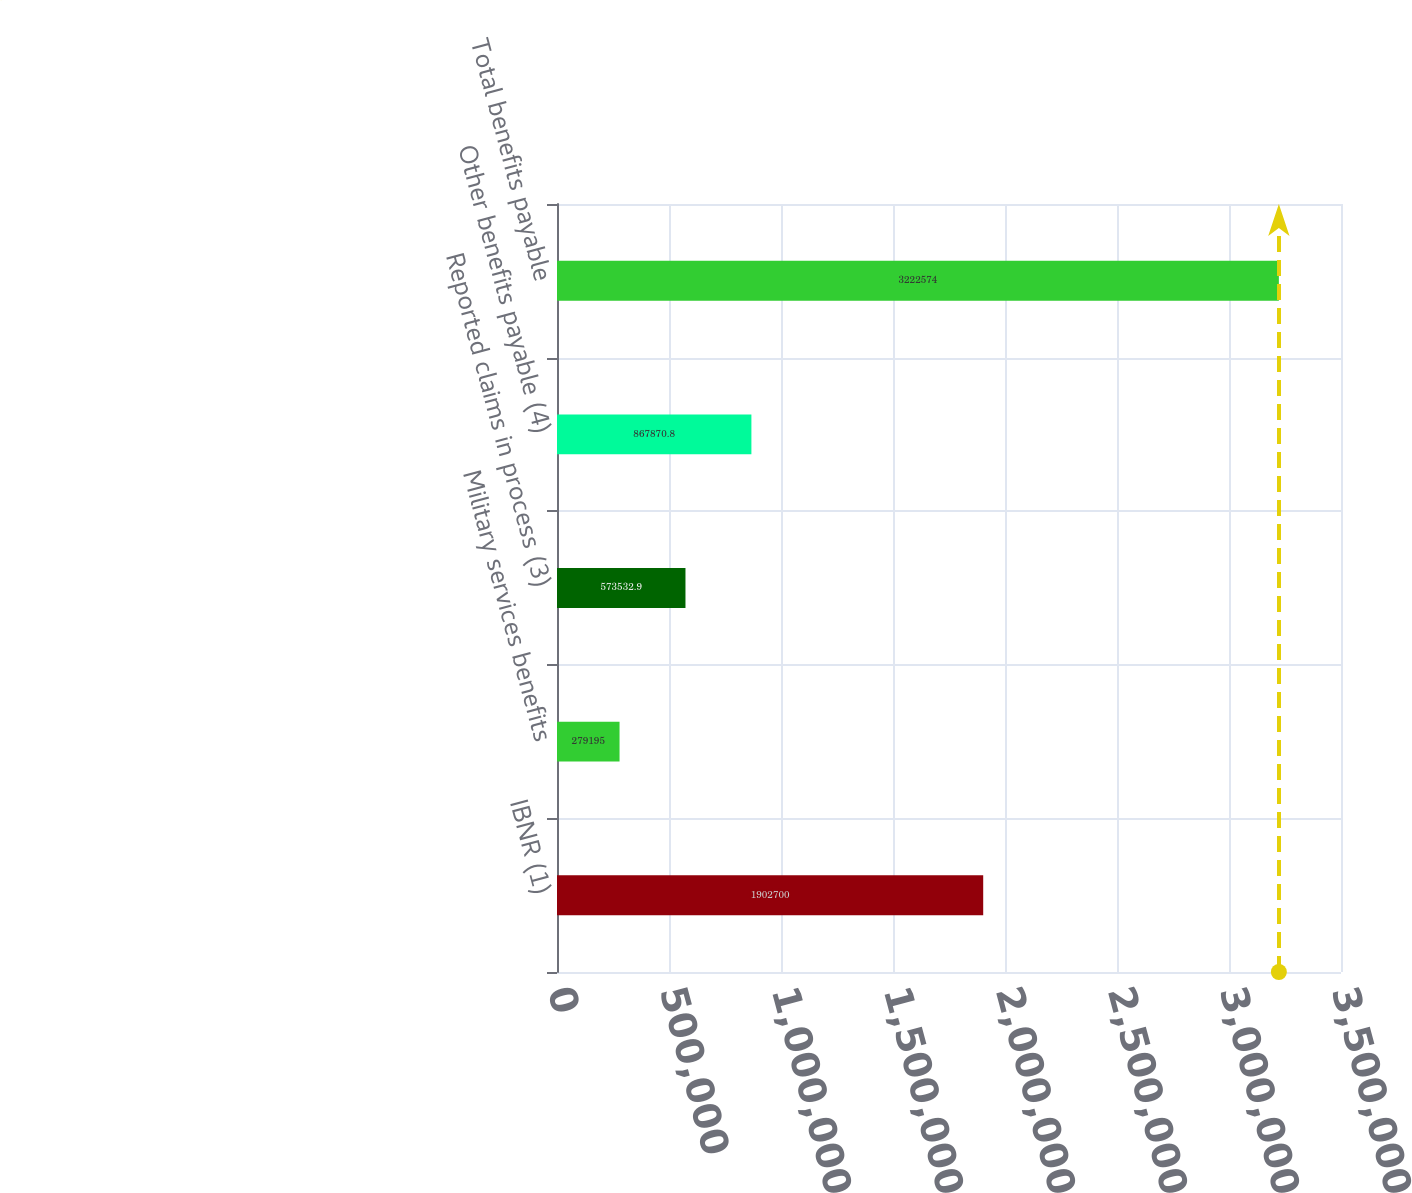<chart> <loc_0><loc_0><loc_500><loc_500><bar_chart><fcel>IBNR (1)<fcel>Military services benefits<fcel>Reported claims in process (3)<fcel>Other benefits payable (4)<fcel>Total benefits payable<nl><fcel>1.9027e+06<fcel>279195<fcel>573533<fcel>867871<fcel>3.22257e+06<nl></chart> 